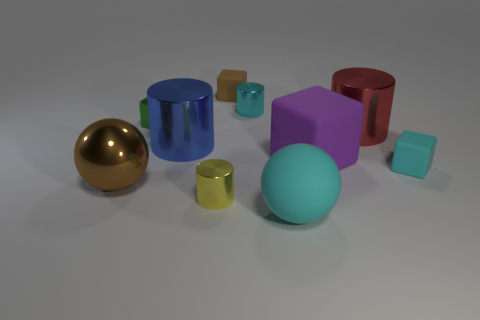Subtract all purple cylinders. Subtract all blue cubes. How many cylinders are left? 4 Subtract all blocks. How many objects are left? 6 Add 3 small rubber blocks. How many small rubber blocks exist? 5 Subtract 1 red cylinders. How many objects are left? 9 Subtract all shiny objects. Subtract all spheres. How many objects are left? 2 Add 2 brown rubber blocks. How many brown rubber blocks are left? 3 